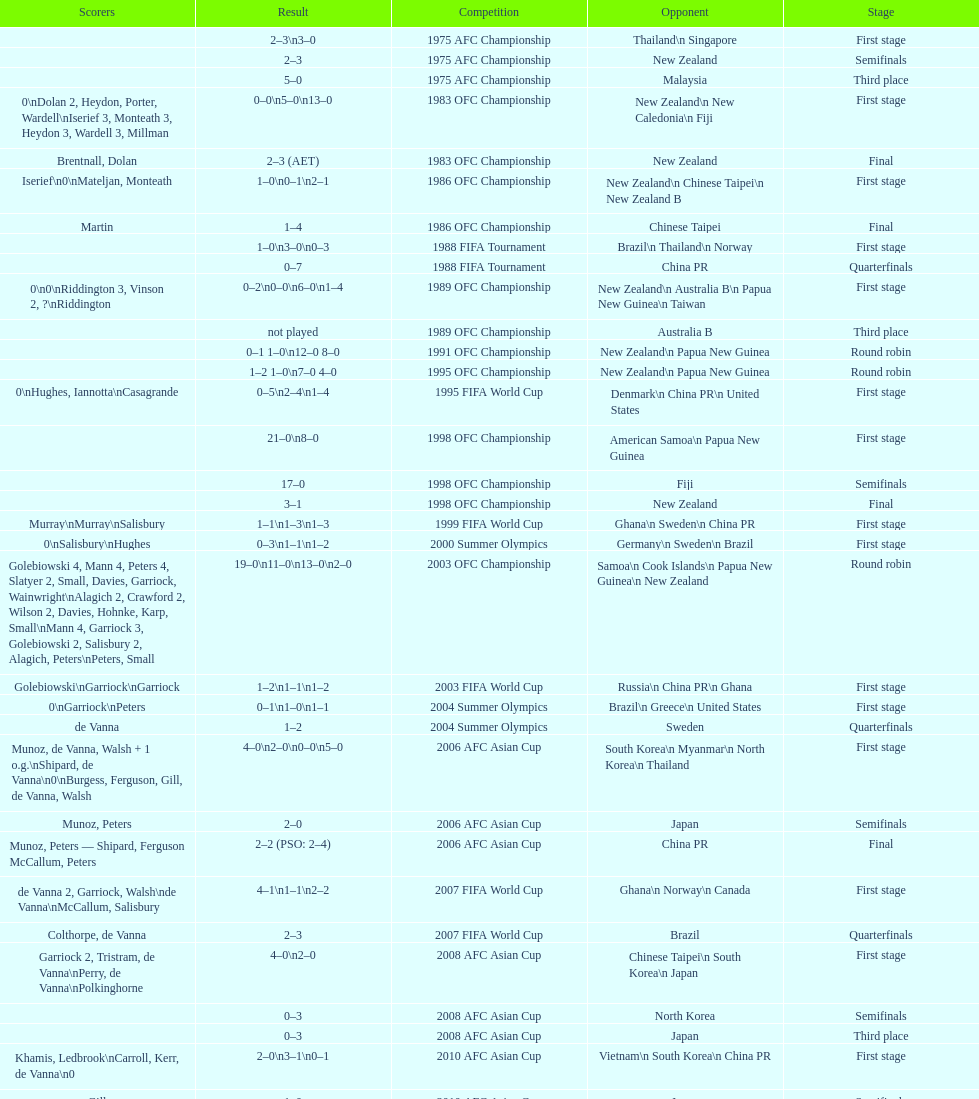How many stages were round robins? 3. 